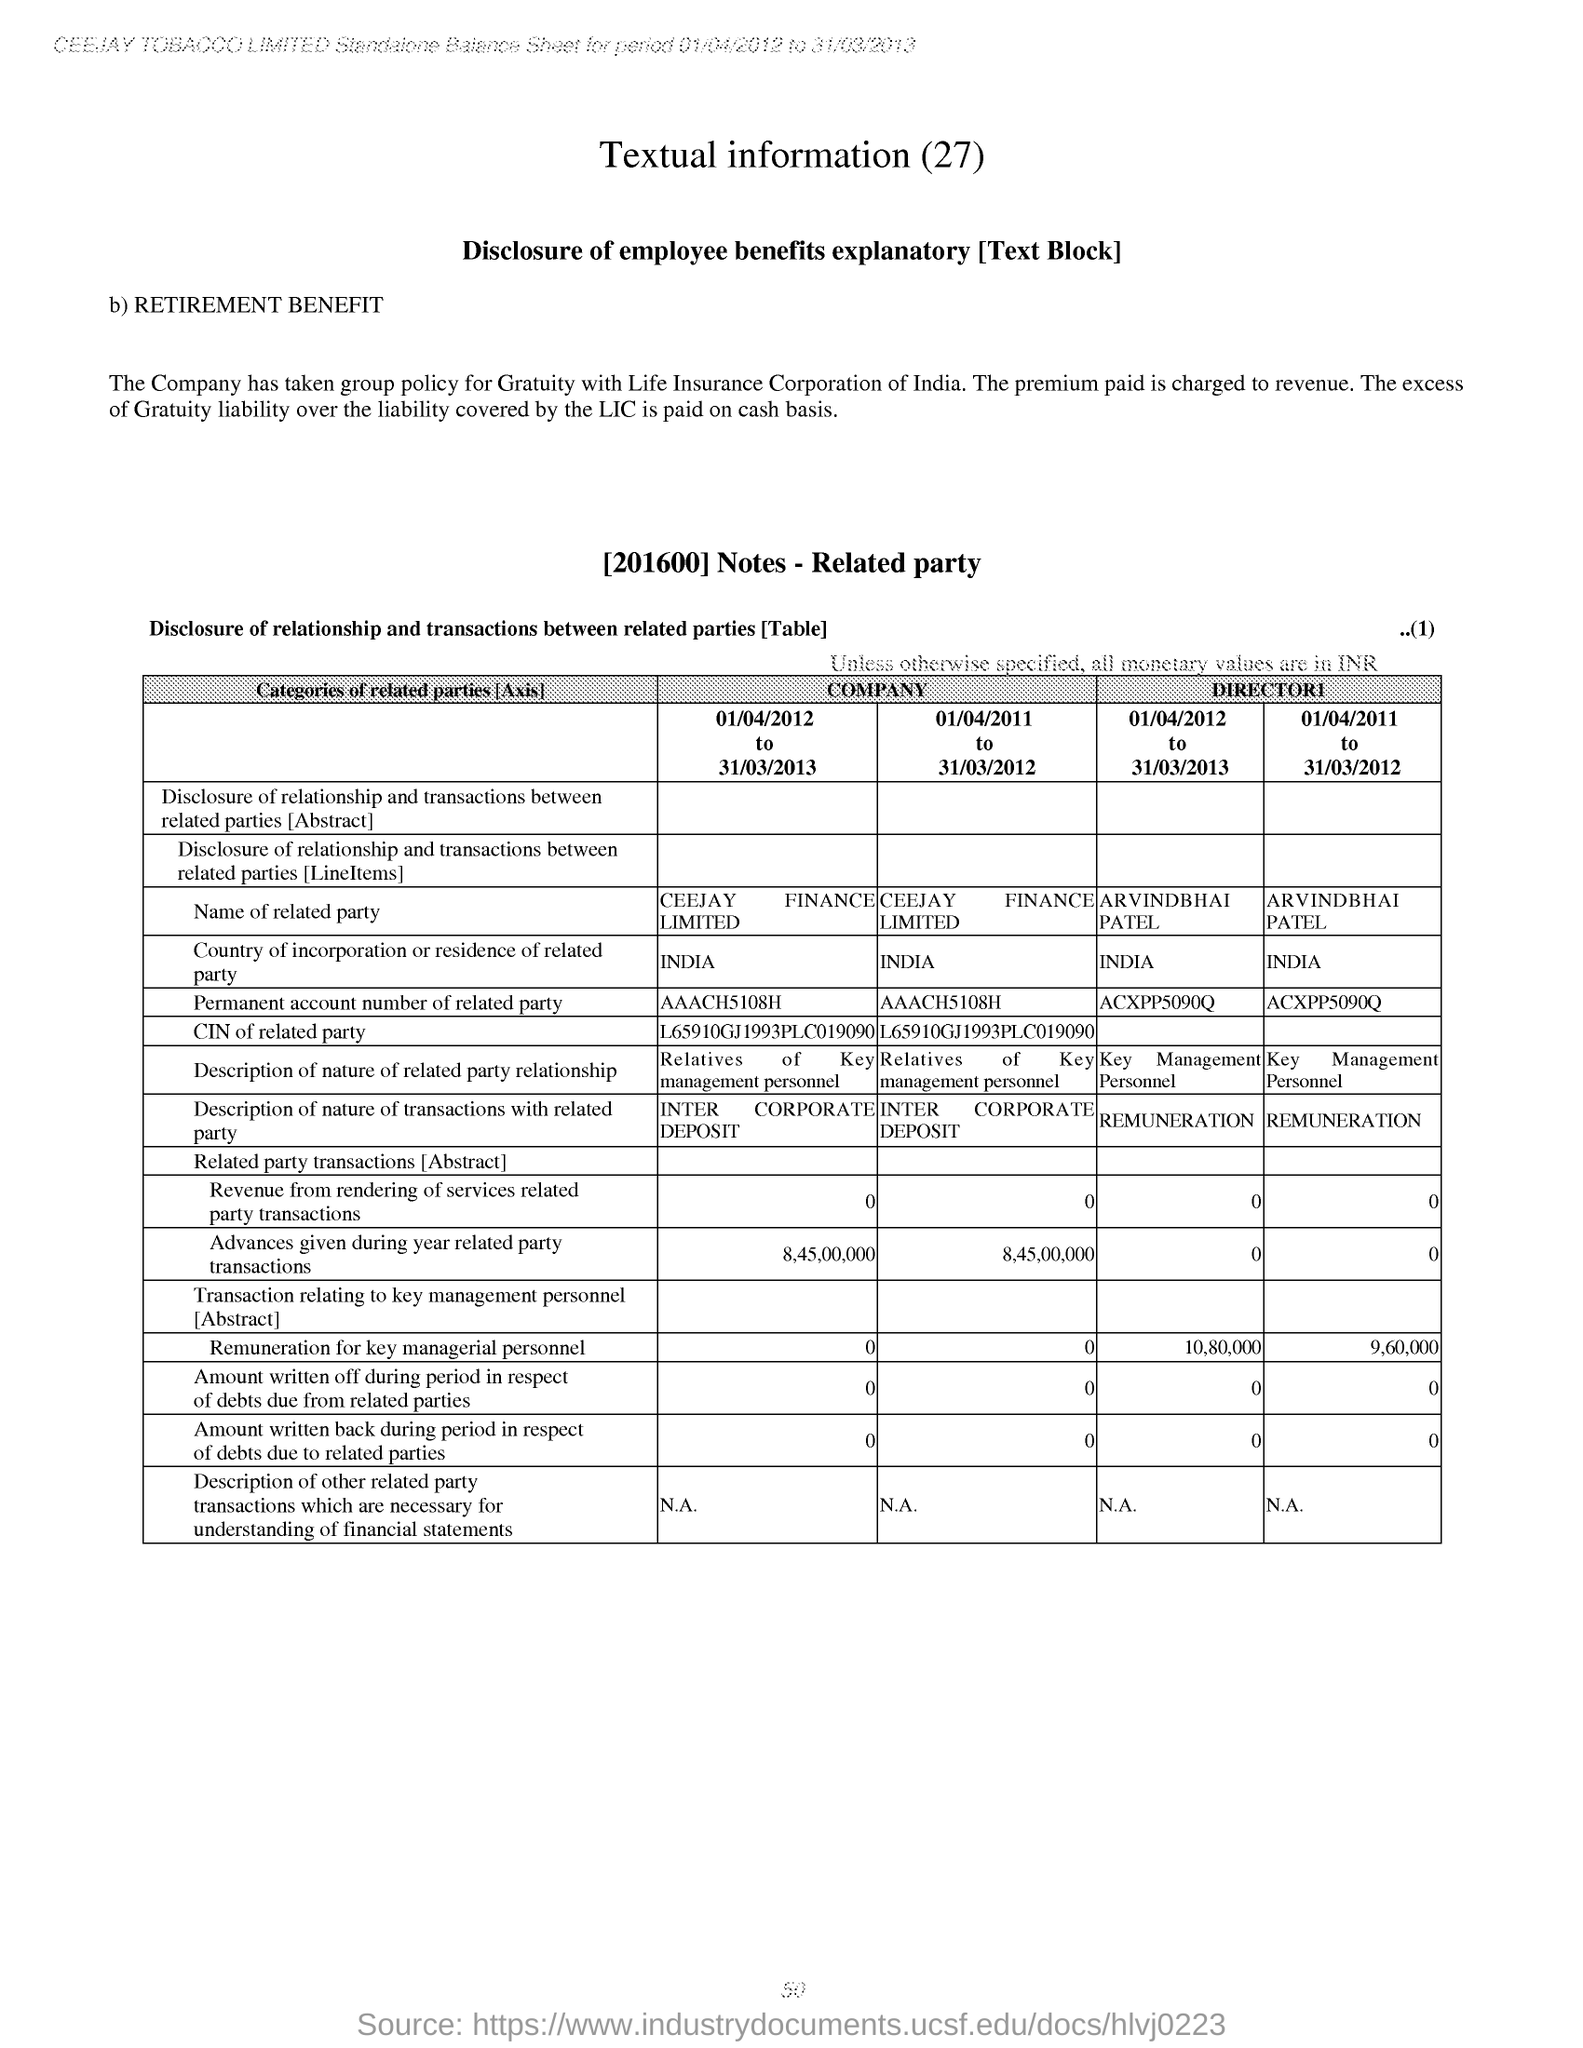List a handful of essential elements in this visual. The heading of the document is 'Textual information (27).'. 